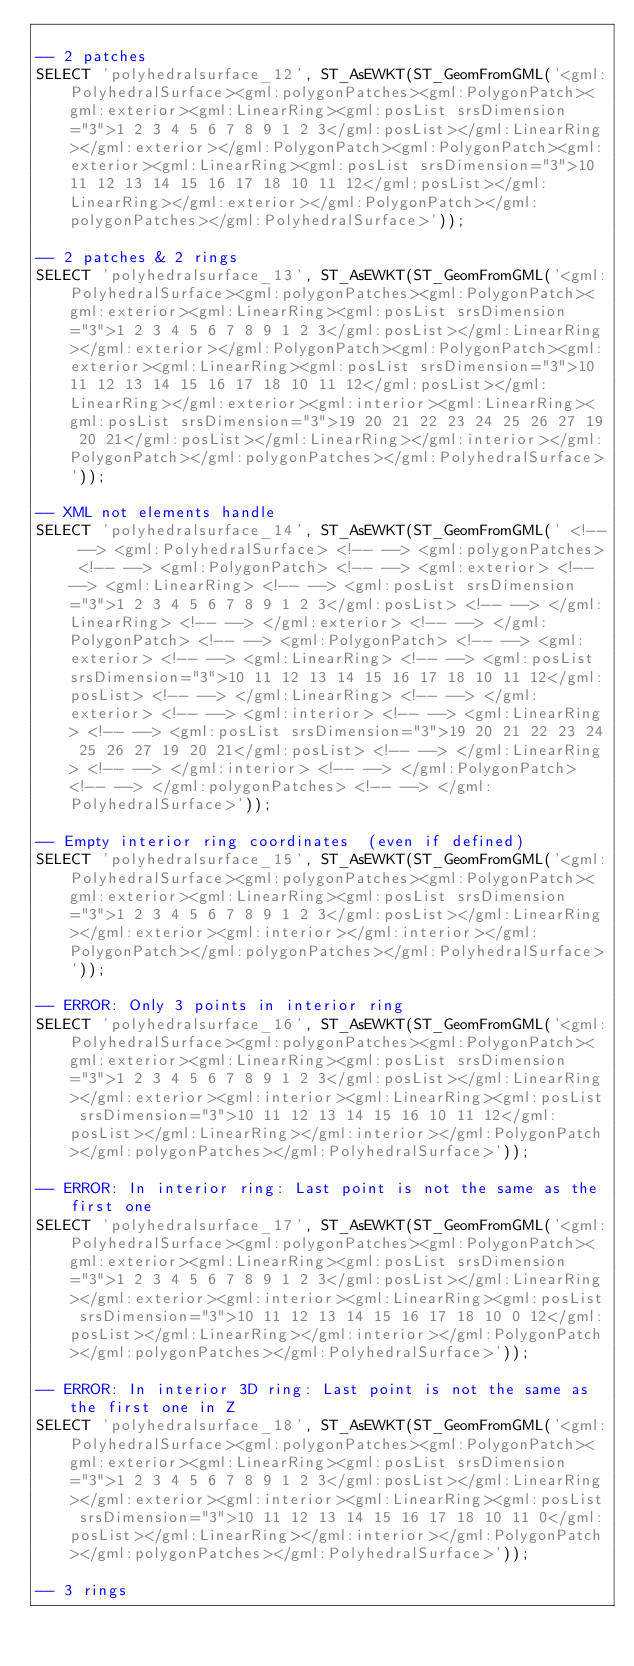<code> <loc_0><loc_0><loc_500><loc_500><_SQL_>
-- 2 patches
SELECT 'polyhedralsurface_12', ST_AsEWKT(ST_GeomFromGML('<gml:PolyhedralSurface><gml:polygonPatches><gml:PolygonPatch><gml:exterior><gml:LinearRing><gml:posList srsDimension="3">1 2 3 4 5 6 7 8 9 1 2 3</gml:posList></gml:LinearRing></gml:exterior></gml:PolygonPatch><gml:PolygonPatch><gml:exterior><gml:LinearRing><gml:posList srsDimension="3">10 11 12 13 14 15 16 17 18 10 11 12</gml:posList></gml:LinearRing></gml:exterior></gml:PolygonPatch></gml:polygonPatches></gml:PolyhedralSurface>'));

-- 2 patches & 2 rings
SELECT 'polyhedralsurface_13', ST_AsEWKT(ST_GeomFromGML('<gml:PolyhedralSurface><gml:polygonPatches><gml:PolygonPatch><gml:exterior><gml:LinearRing><gml:posList srsDimension="3">1 2 3 4 5 6 7 8 9 1 2 3</gml:posList></gml:LinearRing></gml:exterior></gml:PolygonPatch><gml:PolygonPatch><gml:exterior><gml:LinearRing><gml:posList srsDimension="3">10 11 12 13 14 15 16 17 18 10 11 12</gml:posList></gml:LinearRing></gml:exterior><gml:interior><gml:LinearRing><gml:posList srsDimension="3">19 20 21 22 23 24 25 26 27 19 20 21</gml:posList></gml:LinearRing></gml:interior></gml:PolygonPatch></gml:polygonPatches></gml:PolyhedralSurface>'));

-- XML not elements handle
SELECT 'polyhedralsurface_14', ST_AsEWKT(ST_GeomFromGML(' <!-- --> <gml:PolyhedralSurface> <!-- --> <gml:polygonPatches> <!-- --> <gml:PolygonPatch> <!-- --> <gml:exterior> <!-- --> <gml:LinearRing> <!-- --> <gml:posList srsDimension="3">1 2 3 4 5 6 7 8 9 1 2 3</gml:posList> <!-- --> </gml:LinearRing> <!-- --> </gml:exterior> <!-- --> </gml:PolygonPatch> <!-- --> <gml:PolygonPatch> <!-- --> <gml:exterior> <!-- --> <gml:LinearRing> <!-- --> <gml:posList srsDimension="3">10 11 12 13 14 15 16 17 18 10 11 12</gml:posList> <!-- --> </gml:LinearRing> <!-- --> </gml:exterior> <!-- --> <gml:interior> <!-- --> <gml:LinearRing> <!-- --> <gml:posList srsDimension="3">19 20 21 22 23 24 25 26 27 19 20 21</gml:posList> <!-- --> </gml:LinearRing> <!-- --> </gml:interior> <!-- --> </gml:PolygonPatch> <!-- --> </gml:polygonPatches> <!-- --> </gml:PolyhedralSurface>'));

-- Empty interior ring coordinates  (even if defined)
SELECT 'polyhedralsurface_15', ST_AsEWKT(ST_GeomFromGML('<gml:PolyhedralSurface><gml:polygonPatches><gml:PolygonPatch><gml:exterior><gml:LinearRing><gml:posList srsDimension="3">1 2 3 4 5 6 7 8 9 1 2 3</gml:posList></gml:LinearRing></gml:exterior><gml:interior></gml:interior></gml:PolygonPatch></gml:polygonPatches></gml:PolyhedralSurface>'));

-- ERROR: Only 3 points in interior ring
SELECT 'polyhedralsurface_16', ST_AsEWKT(ST_GeomFromGML('<gml:PolyhedralSurface><gml:polygonPatches><gml:PolygonPatch><gml:exterior><gml:LinearRing><gml:posList srsDimension="3">1 2 3 4 5 6 7 8 9 1 2 3</gml:posList></gml:LinearRing></gml:exterior><gml:interior><gml:LinearRing><gml:posList srsDimension="3">10 11 12 13 14 15 16 10 11 12</gml:posList></gml:LinearRing></gml:interior></gml:PolygonPatch></gml:polygonPatches></gml:PolyhedralSurface>'));

-- ERROR: In interior ring: Last point is not the same as the first one
SELECT 'polyhedralsurface_17', ST_AsEWKT(ST_GeomFromGML('<gml:PolyhedralSurface><gml:polygonPatches><gml:PolygonPatch><gml:exterior><gml:LinearRing><gml:posList srsDimension="3">1 2 3 4 5 6 7 8 9 1 2 3</gml:posList></gml:LinearRing></gml:exterior><gml:interior><gml:LinearRing><gml:posList srsDimension="3">10 11 12 13 14 15 16 17 18 10 0 12</gml:posList></gml:LinearRing></gml:interior></gml:PolygonPatch></gml:polygonPatches></gml:PolyhedralSurface>'));

-- ERROR: In interior 3D ring: Last point is not the same as the first one in Z
SELECT 'polyhedralsurface_18', ST_AsEWKT(ST_GeomFromGML('<gml:PolyhedralSurface><gml:polygonPatches><gml:PolygonPatch><gml:exterior><gml:LinearRing><gml:posList srsDimension="3">1 2 3 4 5 6 7 8 9 1 2 3</gml:posList></gml:LinearRing></gml:exterior><gml:interior><gml:LinearRing><gml:posList srsDimension="3">10 11 12 13 14 15 16 17 18 10 11 0</gml:posList></gml:LinearRing></gml:interior></gml:PolygonPatch></gml:polygonPatches></gml:PolyhedralSurface>'));

-- 3 rings</code> 